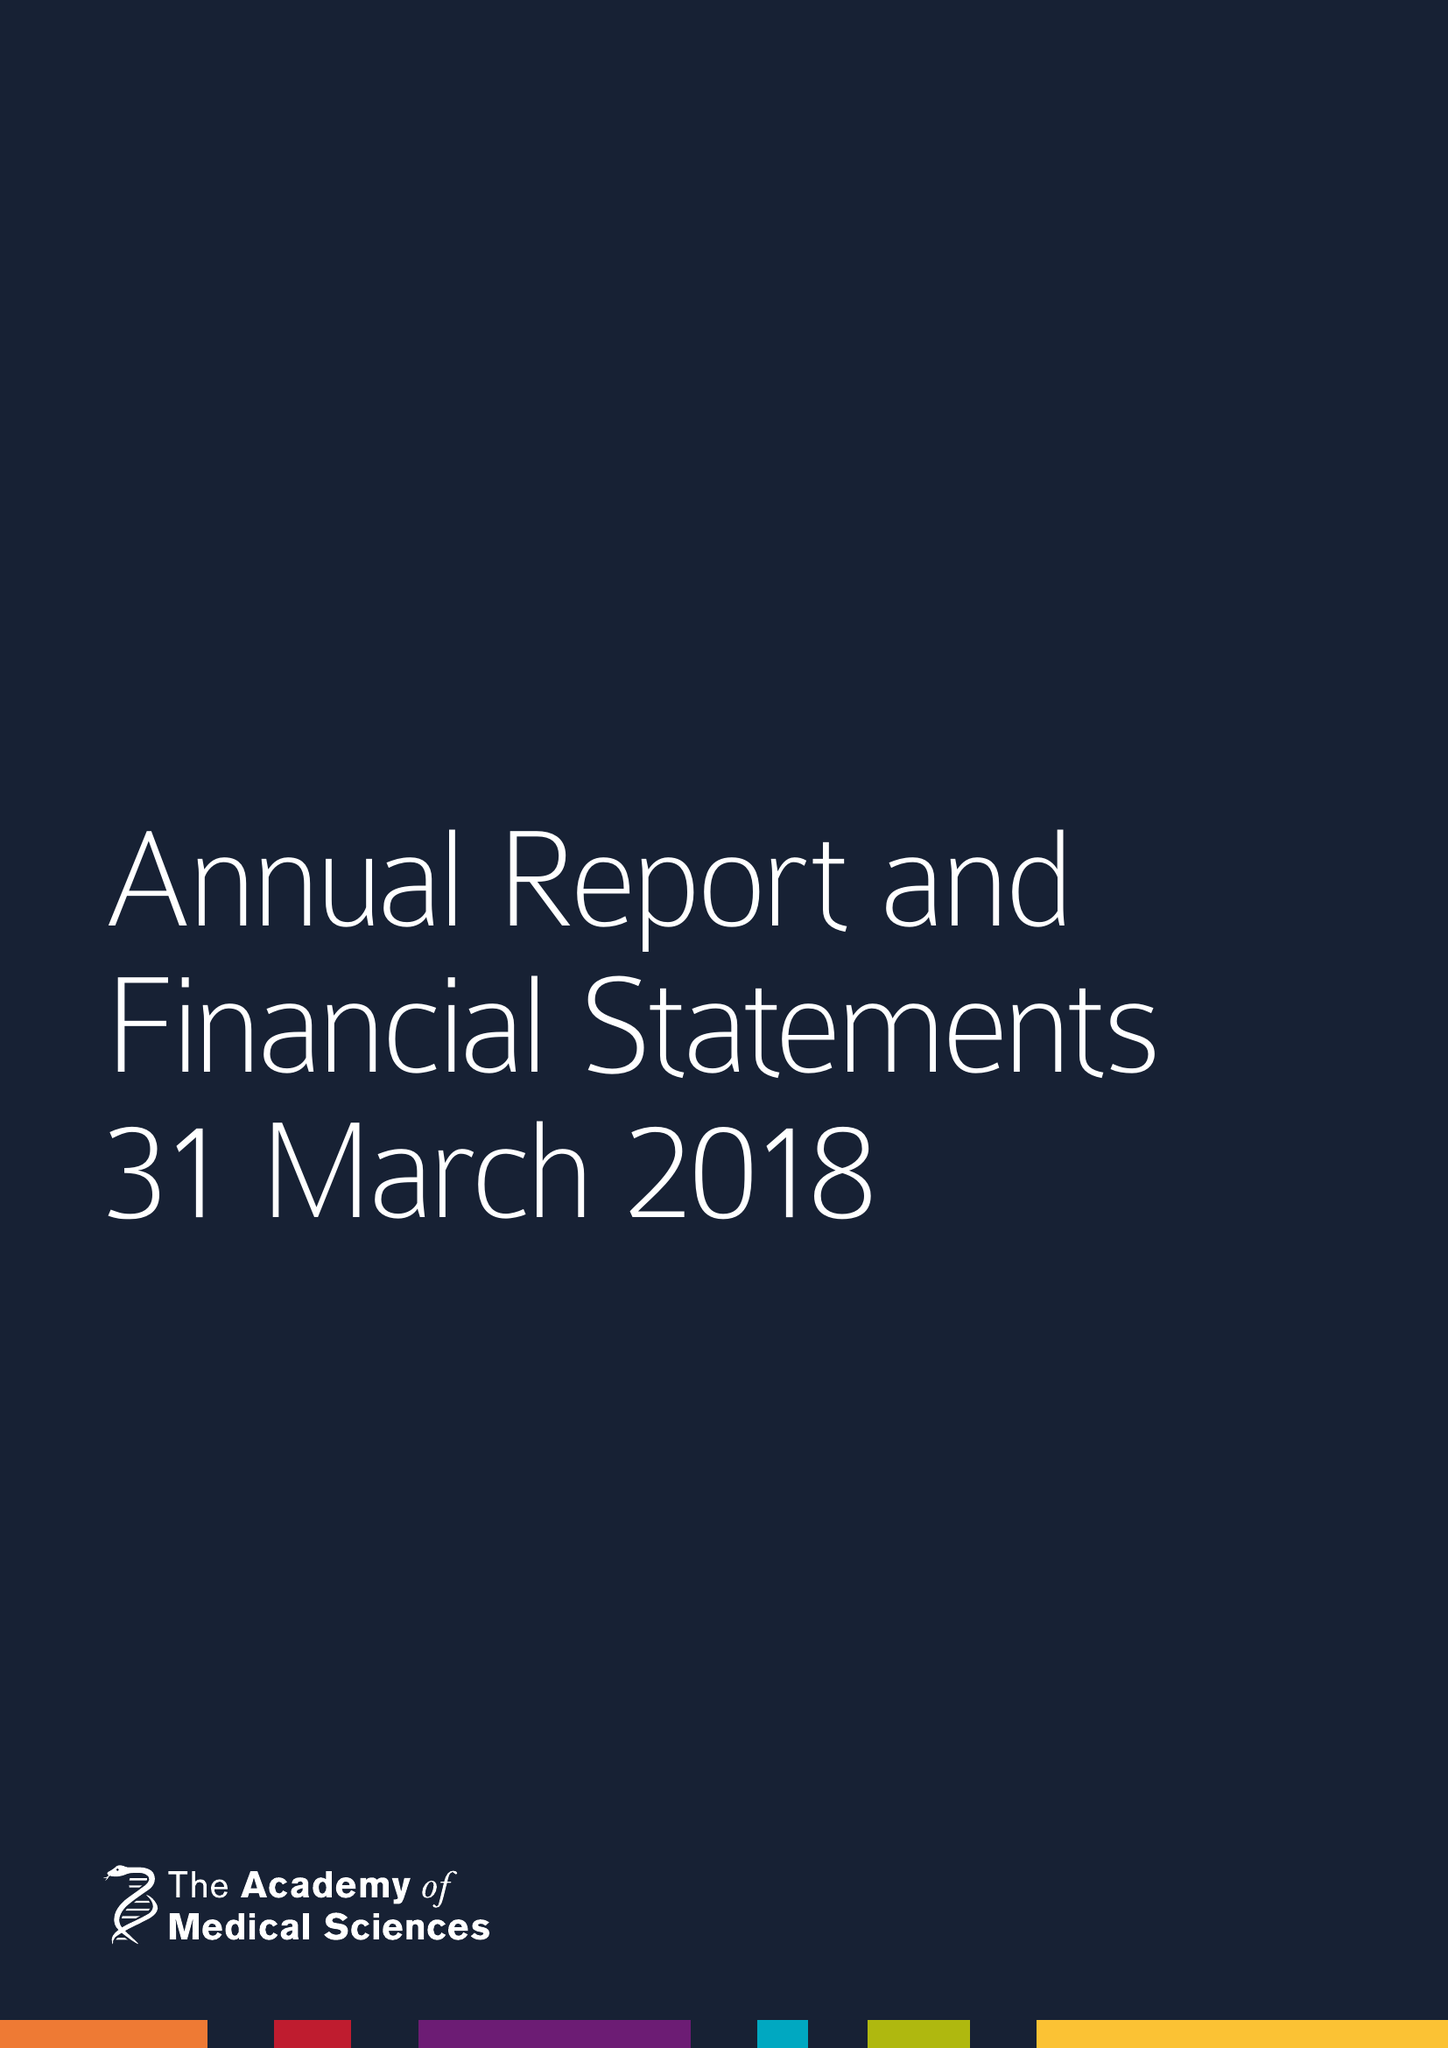What is the value for the address__post_town?
Answer the question using a single word or phrase. LONDON 